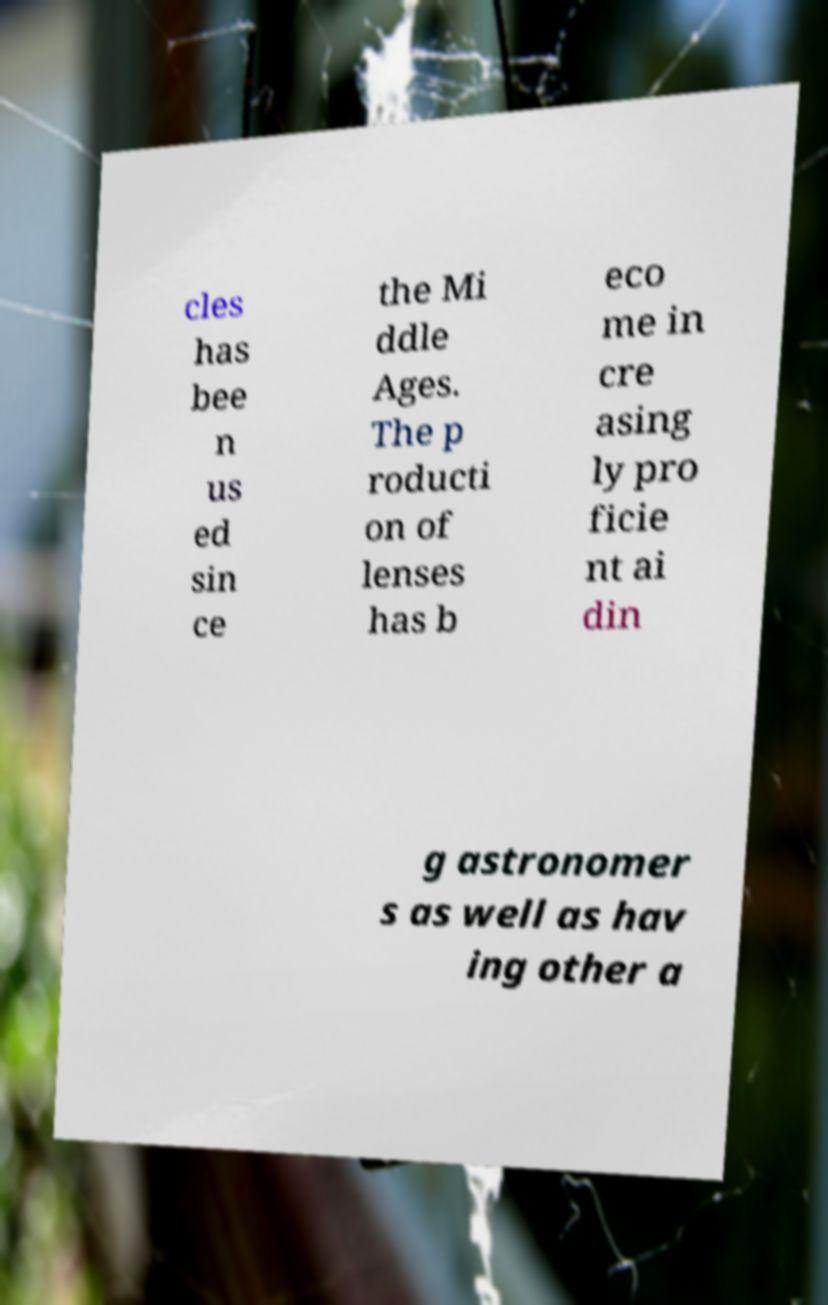For documentation purposes, I need the text within this image transcribed. Could you provide that? cles has bee n us ed sin ce the Mi ddle Ages. The p roducti on of lenses has b eco me in cre asing ly pro ficie nt ai din g astronomer s as well as hav ing other a 